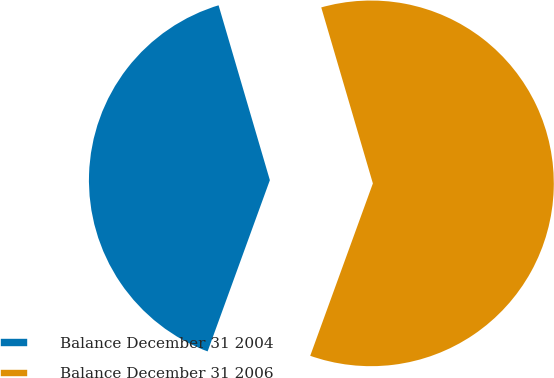<chart> <loc_0><loc_0><loc_500><loc_500><pie_chart><fcel>Balance December 31 2004<fcel>Balance December 31 2006<nl><fcel>39.91%<fcel>60.09%<nl></chart> 